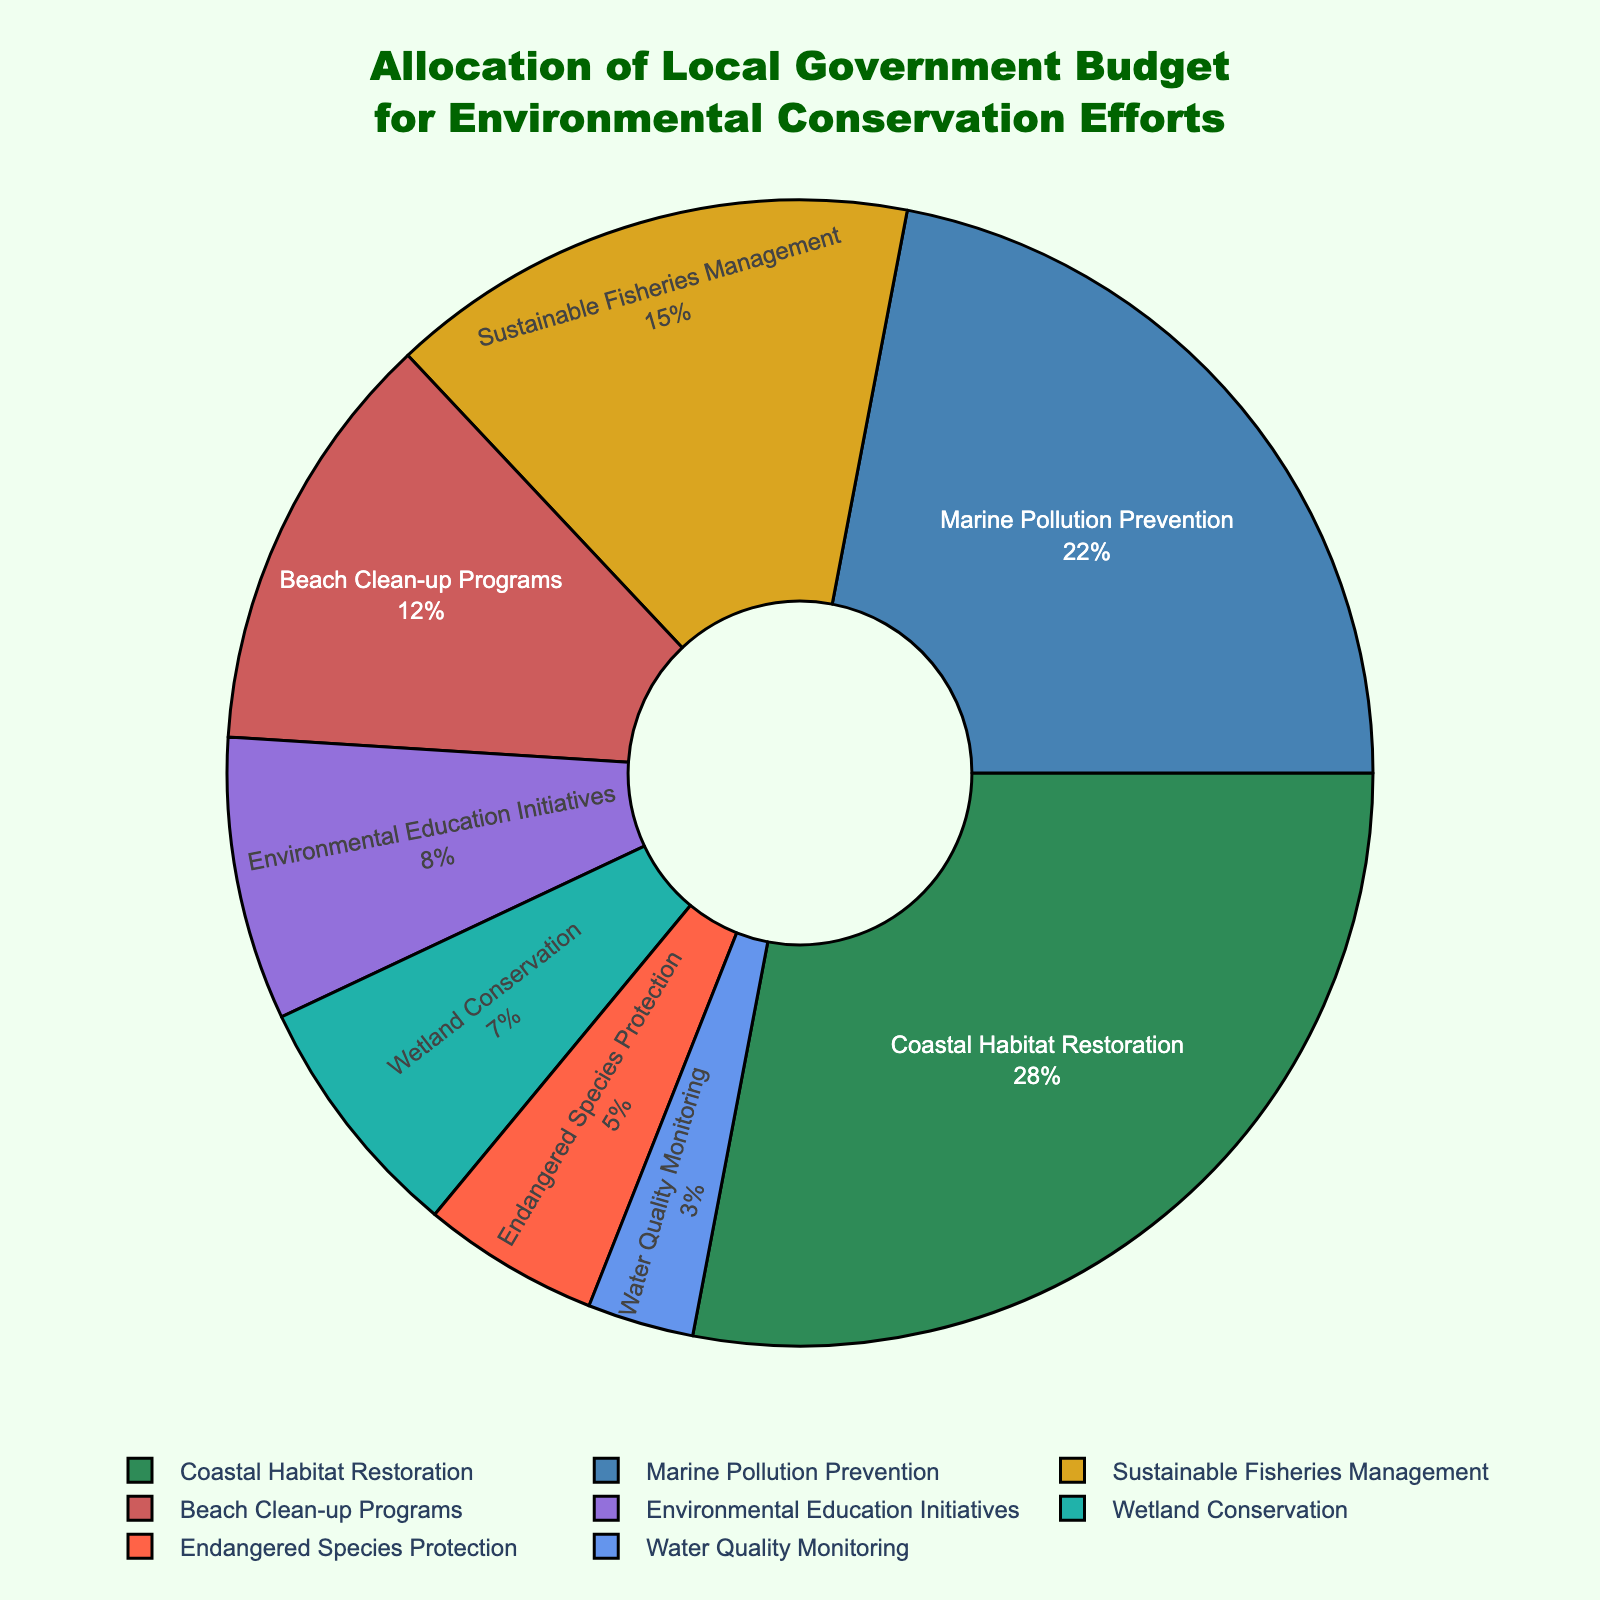What percentage of the budget is allocated to Marine Pollution Prevention and Water Quality Monitoring combined? Marine Pollution Prevention is 22%, and Water Quality Monitoring is 3%. Adding these together, 22% + 3% = 25%.
Answer: 25% Which category has the largest allocation, and what is its percentage? By examining the figure, Coastal Habitat Restoration has the largest budget allocation at 28%.
Answer: Coastal Habitat Restoration, 28% How much more of the budget is allocated to Sustainable Fisheries Management compared to Environmental Education Initiatives? Sustainable Fisheries Management is allocated 15%, and Environmental Education Initiatives is 8%. The difference is 15% - 8% = 7%.
Answer: 7% Which two categories are allocated the same percentage of the budget, and what is the percentage? By looking at the figure, no two categories have the same budget allocation percentage.
Answer: None What is the total percentage of the budget allocated to Beach Clean-up Programs and Endangered Species Protection? Beach Clean-up Programs are 12%, and Endangered Species Protection is 5%. Totaling these gives 12% + 5% = 17%.
Answer: 17% Is more of the budget allocated to Wetland Conservation than Environmental Education Initiatives? Wetland Conservation has a 7% allocation, whereas Environmental Education Initiatives have 8%. 7% < 8%, so less is allocated to Wetland Conservation.
Answer: No What percentage is the smallest allocation, and which category does it belong to? The smallest allocation is 3%, and it belongs to Water Quality Monitoring.
Answer: 3%, Water Quality Monitoring How much more percentage is allocated to Coastal Habitat Restoration than to Endangered Species Protection? Coastal Habitat Restoration is 28%, and Endangered Species Protection is 5%. The difference is 28% - 5% = 23%.
Answer: 23% Which categories together make up at least 50% of the budget? Coastal Habitat Restoration (28%), Marine Pollution Prevention (22%), and either alone or combined make up 50%: 28% + 22% = 50%.
Answer: Coastal Habitat Restoration, Marine Pollution Prevention 